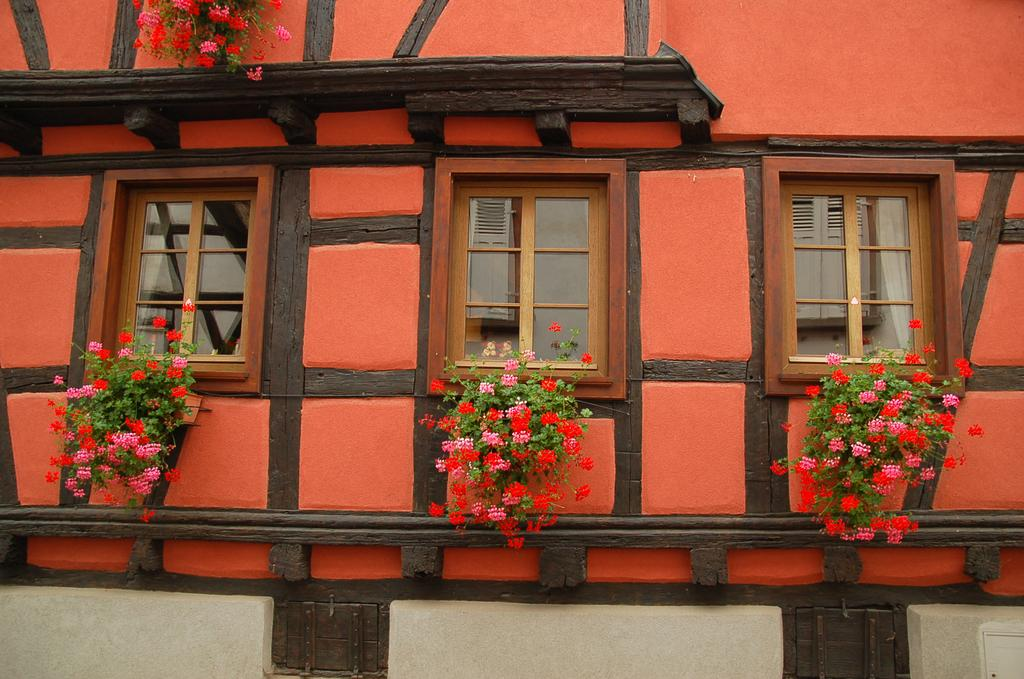What type of structure is visible in the image? There is a building in the image. What feature of the building is mentioned in the facts? The building has windows. What can be seen on a shelf in the image? There are spots on a shelf in the image. What type of objects are present with the plants in the image? There are pots with plants in the image. What additional detail is provided about the plants? The plants have flowers. What type of writing can be seen on the crate in the image? There is no crate present in the image, so no writing can be seen. 